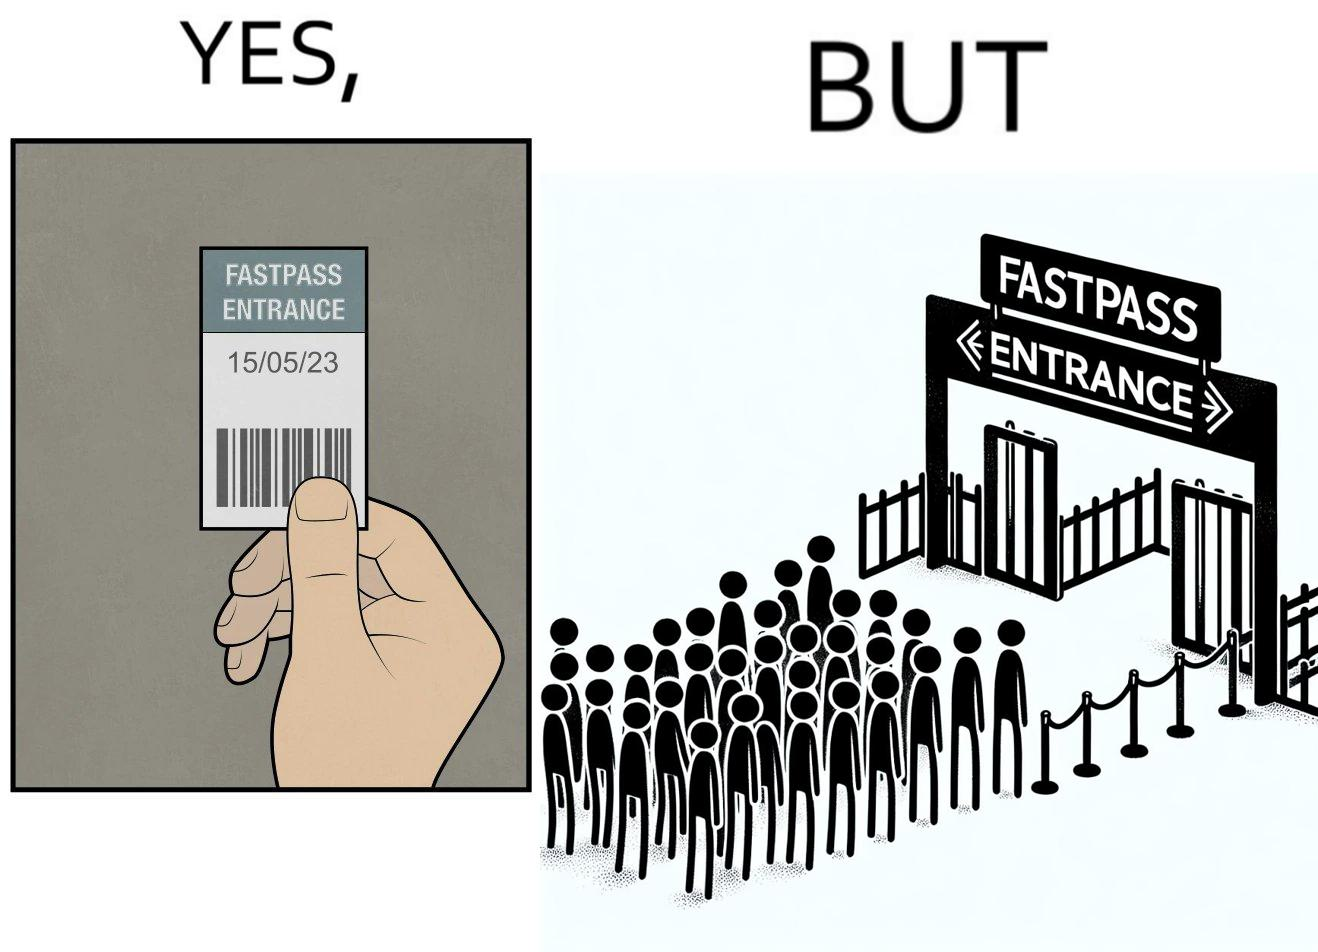What do you see in each half of this image? In the left part of the image: a person holding a "FASTPASS ENTRANCE" ticket or token of date "15/05/23" with some barcode In the right part of the image: people in a long queue in front of "FASTPASS ENTRANCE"  gate and "ENTRANCE" gate is vacant without any queue 